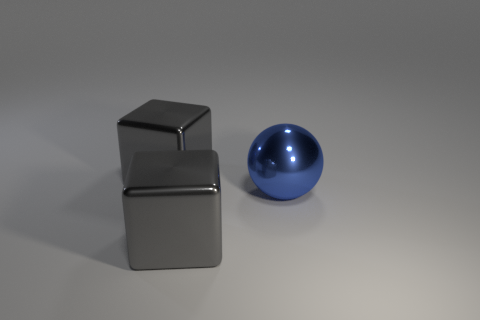Add 2 large metallic balls. How many objects exist? 5 Subtract all balls. How many objects are left? 2 Subtract 0 green balls. How many objects are left? 3 Subtract all gray shiny cubes. Subtract all metal spheres. How many objects are left? 0 Add 1 gray objects. How many gray objects are left? 3 Add 3 large metallic objects. How many large metallic objects exist? 6 